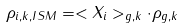<formula> <loc_0><loc_0><loc_500><loc_500>\rho _ { i , k , I S M } = < X _ { i } > _ { g , k } \cdot \rho _ { g , k }</formula> 